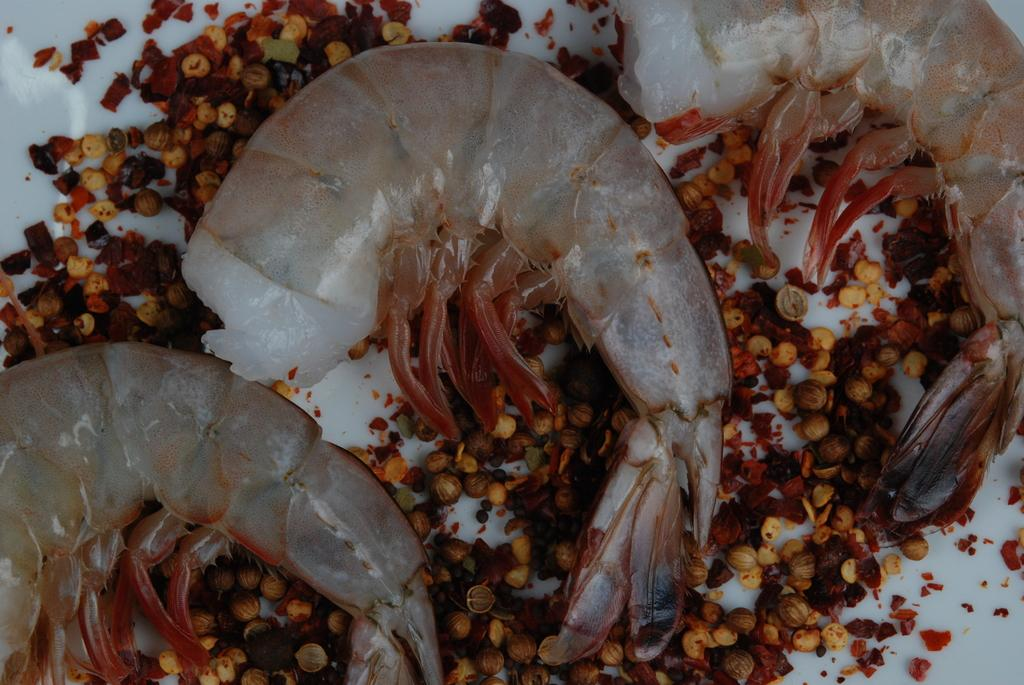What type of seafood is present in the image? There are prawns in the image. What other items can be seen with the prawns? There are other ingredients in the image. What color is the surface the prawns and ingredients are on? The surface the prawns and ingredients are on is white. What type of view can be seen from the tramp in the image? There is no tramp present in the image, so it is not possible to answer that question. 